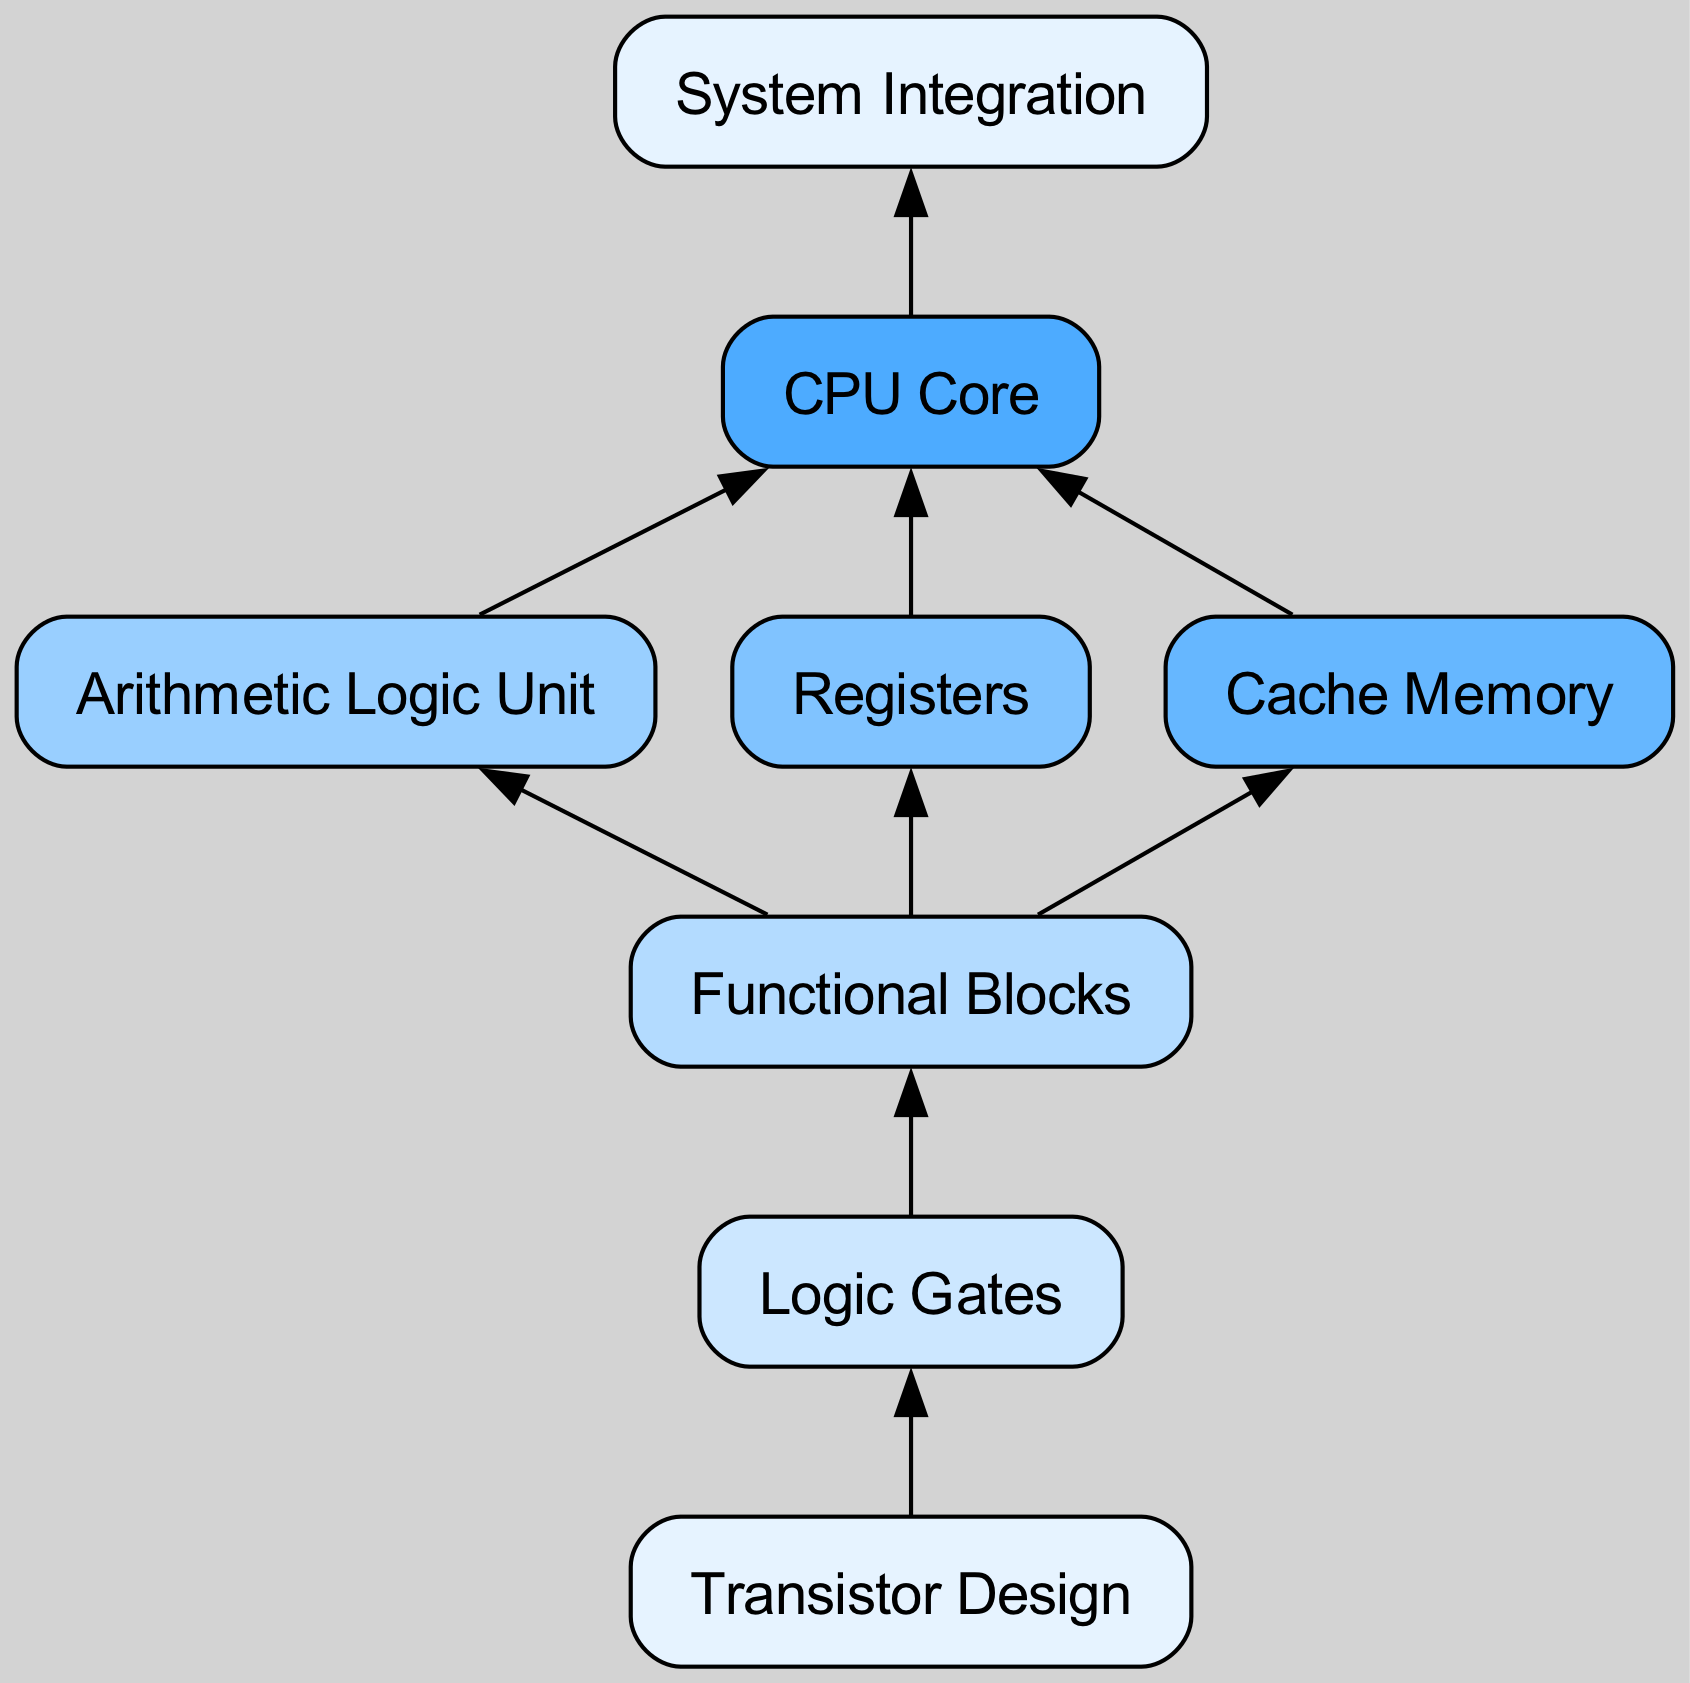What is the top-level design process element in the diagram? The diagram starts with the "Transistor Design" as the bottom-most node, representing the initial stage of the chip design process and flows upwards.
Answer: Transistor Design How many child elements does the "Functional Blocks" node have? The "Functional Blocks" node has three child elements: "Arithmetic Logic Unit," "Registers," and "Cache Memory," totaling three children.
Answer: 3 What is the relationship between "Cache Memory" and "CPU Core"? "Cache Memory" is a child element of "Functional Blocks" and has a direct connection to the "CPU Core" as evidenced by its inclusion in the flow leading to it.
Answer: Cache Memory to CPU Core Which node is directly above the "Registers" node? The "Registers" node has "Functional Blocks" as its direct parent, indicating the organization of nodes in a hierarchical manner.
Answer: Functional Blocks What is the last stage of the chip design process depicted in the diagram? The last stage is represented by the "System Integration" node, which signifies the culmination of various elements into a singular integrated system.
Answer: System Integration How many edges connect the "CPU Core" to its children? The "CPU Core" node connects to a single child element named "System Integration," resulting in a single direct edge.
Answer: 1 What sequence identifies the flow from the bottom-most node to the top-most node? The sequence flows upward starting from "Transistor Design," progressing through "Logic Gates," "Functional Blocks," "CPU Core," and culminating at "System Integration."
Answer: Transistor Design, Logic Gates, Functional Blocks, CPU Core, System Integration What type of nodes can be found under "Functional Blocks"? The nodes under "Functional Blocks" are "Arithmetic Logic Unit," "Registers," and "Cache Memory," showcasing the various essential components that comprise this hierarchical level.
Answer: Arithmetic Logic Unit, Registers, Cache Memory What is the total number of nodes in the diagram? By counting the nodes, we have eight elements: "Transistor Design," "Logic Gates," "Functional Blocks," "Arithmetic Logic Unit," "Registers," "Cache Memory," "CPU Core," and "System Integration."
Answer: 8 